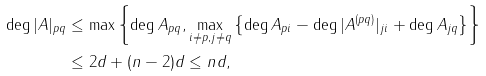Convert formula to latex. <formula><loc_0><loc_0><loc_500><loc_500>\deg | A | _ { p q } & \leq \max \left \{ \deg A _ { p q } , \max _ { i \neq p , j \neq q } \left \{ \deg A _ { p i } - \deg | A ^ { ( p q ) } | _ { j i } + \deg A _ { j q } \right \} \right \} \\ & \leq 2 d + ( n - 2 ) d \leq n d ,</formula> 